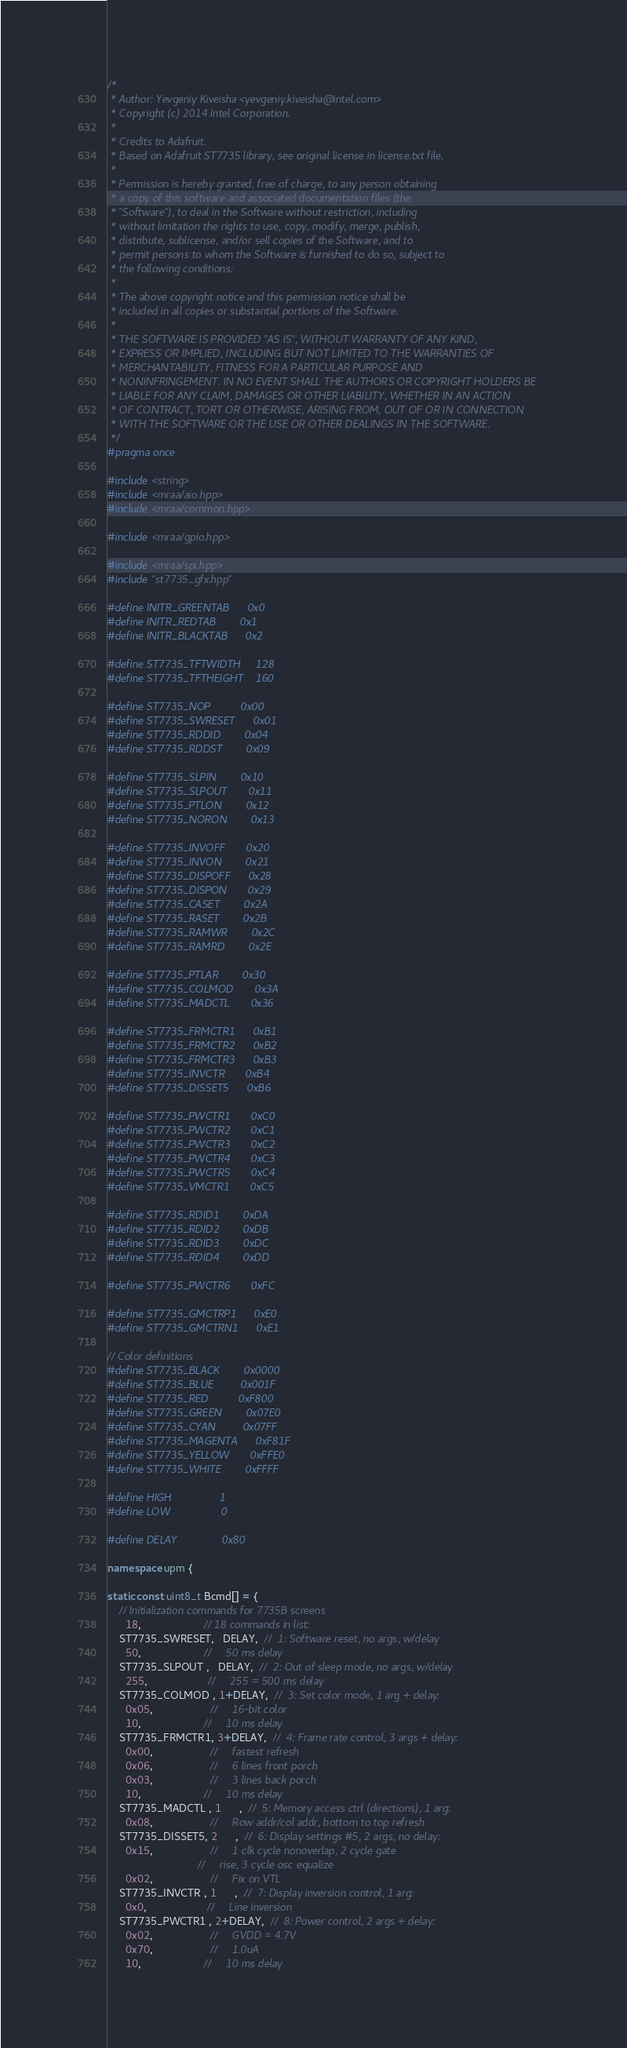<code> <loc_0><loc_0><loc_500><loc_500><_C++_>/*
 * Author: Yevgeniy Kiveisha <yevgeniy.kiveisha@intel.com>
 * Copyright (c) 2014 Intel Corporation.
 *
 * Credits to Adafruit.
 * Based on Adafruit ST7735 library, see original license in license.txt file.
 *
 * Permission is hereby granted, free of charge, to any person obtaining
 * a copy of this software and associated documentation files (the
 * "Software"), to deal in the Software without restriction, including
 * without limitation the rights to use, copy, modify, merge, publish,
 * distribute, sublicense, and/or sell copies of the Software, and to
 * permit persons to whom the Software is furnished to do so, subject to
 * the following conditions:
 *
 * The above copyright notice and this permission notice shall be
 * included in all copies or substantial portions of the Software.
 *
 * THE SOFTWARE IS PROVIDED "AS IS", WITHOUT WARRANTY OF ANY KIND,
 * EXPRESS OR IMPLIED, INCLUDING BUT NOT LIMITED TO THE WARRANTIES OF
 * MERCHANTABILITY, FITNESS FOR A PARTICULAR PURPOSE AND
 * NONINFRINGEMENT. IN NO EVENT SHALL THE AUTHORS OR COPYRIGHT HOLDERS BE
 * LIABLE FOR ANY CLAIM, DAMAGES OR OTHER LIABILITY, WHETHER IN AN ACTION
 * OF CONTRACT, TORT OR OTHERWISE, ARISING FROM, OUT OF OR IN CONNECTION
 * WITH THE SOFTWARE OR THE USE OR OTHER DEALINGS IN THE SOFTWARE.
 */
#pragma once

#include <string>
#include <mraa/aio.hpp>
#include <mraa/common.hpp>

#include <mraa/gpio.hpp>

#include <mraa/spi.hpp>
#include "st7735_gfx.hpp"

#define INITR_GREENTAB      0x0
#define INITR_REDTAB        0x1
#define INITR_BLACKTAB      0x2

#define ST7735_TFTWIDTH     128
#define ST7735_TFTHEIGHT    160

#define ST7735_NOP          0x00
#define ST7735_SWRESET      0x01
#define ST7735_RDDID        0x04
#define ST7735_RDDST        0x09

#define ST7735_SLPIN        0x10
#define ST7735_SLPOUT       0x11
#define ST7735_PTLON        0x12
#define ST7735_NORON        0x13

#define ST7735_INVOFF       0x20
#define ST7735_INVON        0x21
#define ST7735_DISPOFF      0x28
#define ST7735_DISPON       0x29
#define ST7735_CASET        0x2A
#define ST7735_RASET        0x2B
#define ST7735_RAMWR        0x2C
#define ST7735_RAMRD        0x2E

#define ST7735_PTLAR        0x30
#define ST7735_COLMOD       0x3A
#define ST7735_MADCTL       0x36

#define ST7735_FRMCTR1      0xB1
#define ST7735_FRMCTR2      0xB2
#define ST7735_FRMCTR3      0xB3
#define ST7735_INVCTR       0xB4
#define ST7735_DISSET5      0xB6

#define ST7735_PWCTR1       0xC0
#define ST7735_PWCTR2       0xC1
#define ST7735_PWCTR3       0xC2
#define ST7735_PWCTR4       0xC3
#define ST7735_PWCTR5       0xC4
#define ST7735_VMCTR1       0xC5

#define ST7735_RDID1        0xDA
#define ST7735_RDID2        0xDB
#define ST7735_RDID3        0xDC
#define ST7735_RDID4        0xDD

#define ST7735_PWCTR6       0xFC

#define ST7735_GMCTRP1      0xE0
#define ST7735_GMCTRN1      0xE1

// Color definitions
#define ST7735_BLACK        0x0000
#define ST7735_BLUE         0x001F
#define ST7735_RED          0xF800
#define ST7735_GREEN        0x07E0
#define ST7735_CYAN         0x07FF
#define ST7735_MAGENTA      0xF81F
#define ST7735_YELLOW       0xFFE0
#define ST7735_WHITE        0xFFFF

#define HIGH                1
#define LOW                 0

#define DELAY               0x80

namespace upm {

static const uint8_t Bcmd[] = {
    // Initialization commands for 7735B screens
      18,                     // 18 commands in list:
    ST7735_SWRESET,   DELAY,  //  1: Software reset, no args, w/delay
      50,                     //     50 ms delay
    ST7735_SLPOUT ,   DELAY,  //  2: Out of sleep mode, no args, w/delay
      255,                    //     255 = 500 ms delay
    ST7735_COLMOD , 1+DELAY,  //  3: Set color mode, 1 arg + delay:
      0x05,                   //     16-bit color
      10,                     //     10 ms delay
    ST7735_FRMCTR1, 3+DELAY,  //  4: Frame rate control, 3 args + delay:
      0x00,                   //     fastest refresh
      0x06,                   //     6 lines front porch
      0x03,                   //     3 lines back porch
      10,                     //     10 ms delay
    ST7735_MADCTL , 1      ,  //  5: Memory access ctrl (directions), 1 arg:
      0x08,                   //     Row addr/col addr, bottom to top refresh
    ST7735_DISSET5, 2      ,  //  6: Display settings #5, 2 args, no delay:
      0x15,                   //     1 clk cycle nonoverlap, 2 cycle gate
                              //     rise, 3 cycle osc equalize
      0x02,                   //     Fix on VTL
    ST7735_INVCTR , 1      ,  //  7: Display inversion control, 1 arg:
      0x0,                    //     Line inversion
    ST7735_PWCTR1 , 2+DELAY,  //  8: Power control, 2 args + delay:
      0x02,                   //     GVDD = 4.7V
      0x70,                   //     1.0uA
      10,                     //     10 ms delay</code> 